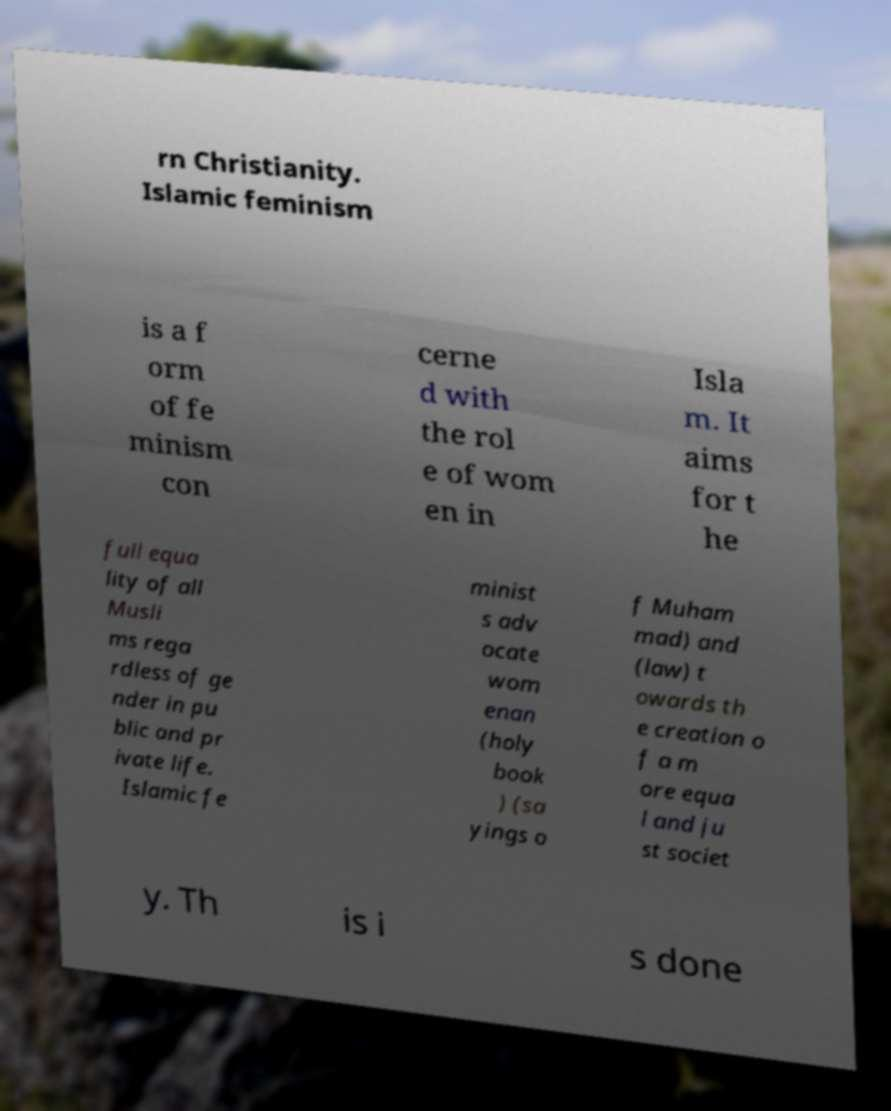Please identify and transcribe the text found in this image. rn Christianity. Islamic feminism is a f orm of fe minism con cerne d with the rol e of wom en in Isla m. It aims for t he full equa lity of all Musli ms rega rdless of ge nder in pu blic and pr ivate life. Islamic fe minist s adv ocate wom enan (holy book ) (sa yings o f Muham mad) and (law) t owards th e creation o f a m ore equa l and ju st societ y. Th is i s done 